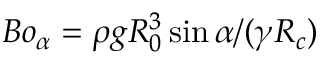Convert formula to latex. <formula><loc_0><loc_0><loc_500><loc_500>B o _ { \alpha } = \rho g R _ { 0 } ^ { 3 } \sin { \alpha } / ( \gamma R _ { c } )</formula> 